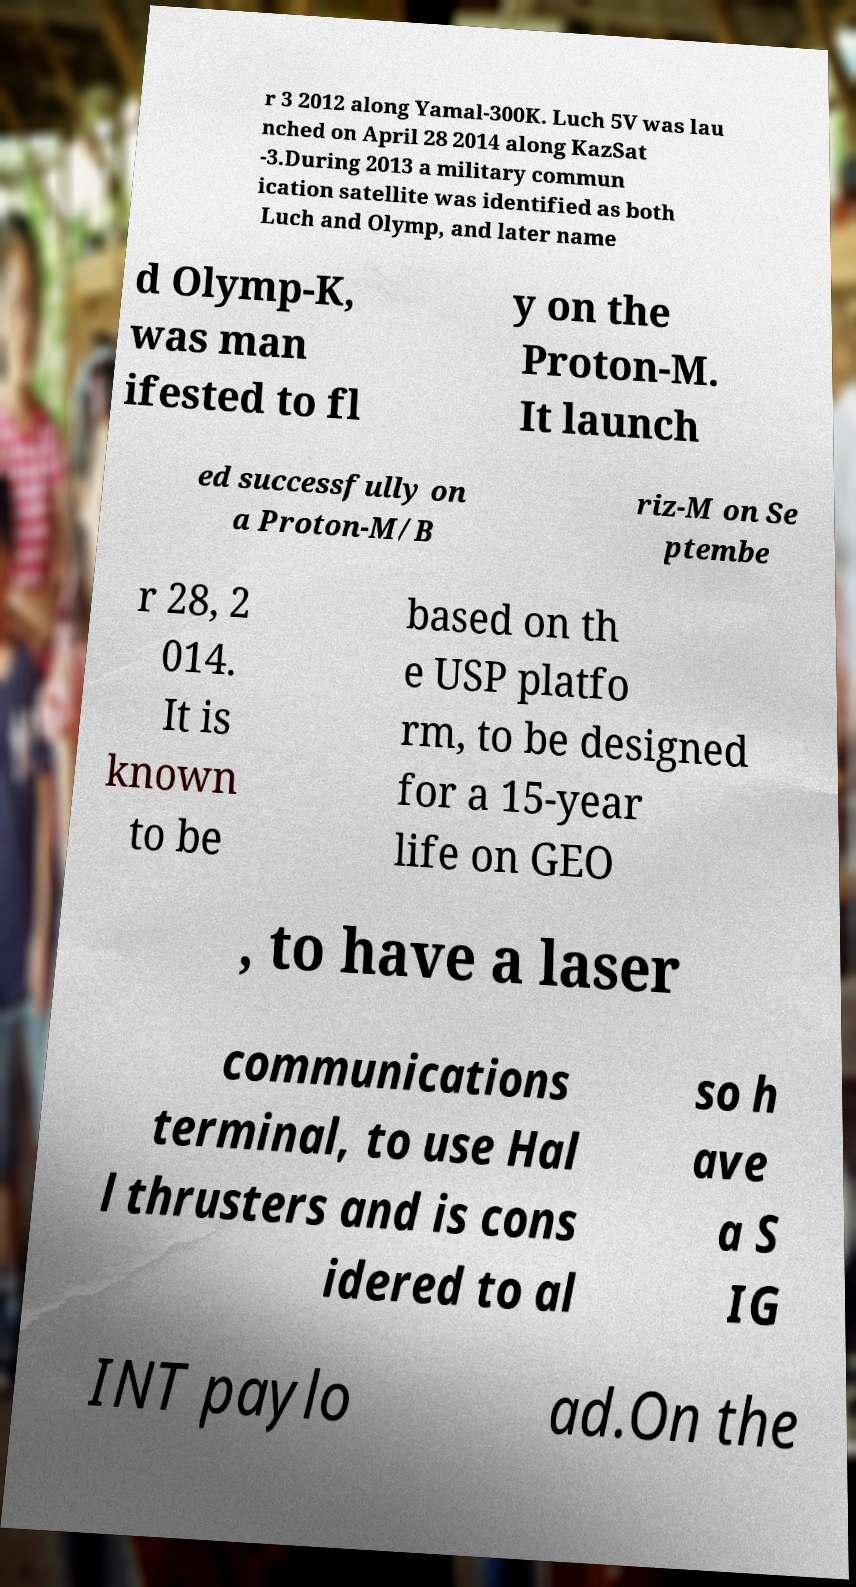Could you extract and type out the text from this image? r 3 2012 along Yamal-300K. Luch 5V was lau nched on April 28 2014 along KazSat -3.During 2013 a military commun ication satellite was identified as both Luch and Olymp, and later name d Olymp-K, was man ifested to fl y on the Proton-M. It launch ed successfully on a Proton-M/B riz-M on Se ptembe r 28, 2 014. It is known to be based on th e USP platfo rm, to be designed for a 15-year life on GEO , to have a laser communications terminal, to use Hal l thrusters and is cons idered to al so h ave a S IG INT paylo ad.On the 